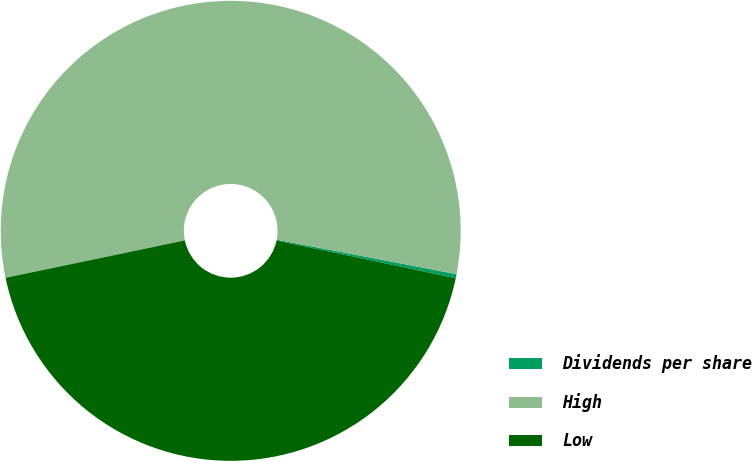<chart> <loc_0><loc_0><loc_500><loc_500><pie_chart><fcel>Dividends per share<fcel>High<fcel>Low<nl><fcel>0.29%<fcel>56.29%<fcel>43.42%<nl></chart> 